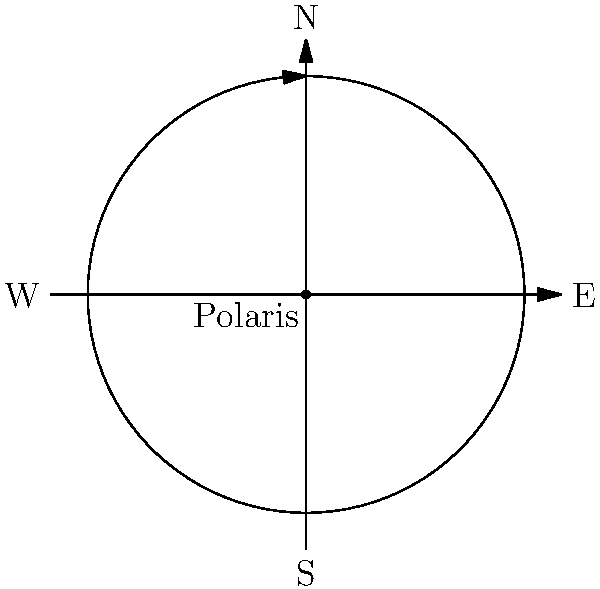Oh, enlightened stargazer, behold this celestial portrait of stellar narcissism! If one were to capture the apparent motion of stars over the course of a night using long-exposure photography, which philosophical conundrum would this circular pattern around Polaris most closely resemble: Nietzsche's eternal recurrence or Plato's allegory of the cave? Let's deconstruct this cosmic spectacle with the irreverence it deserves:

1. The diagram shows a circular pattern around a central point labeled "Polaris," our cosmic narcissist.

2. This pattern represents star trails, the apparent motion of stars in the night sky as observed from Earth.

3. The circular motion occurs because:
   a) Earth rotates on its axis.
   b) Polaris, our celestial anchor, is aligned with Earth's rotational axis.

4. Now, for the philosophical musings:
   a) Nietzsche's eternal recurrence posits that the universe and all existence recur infinitely.
   b) Plato's allegory of the cave suggests that our perceptions may not reflect true reality.

5. The star trail pattern:
   a) Repeats nightly, echoing Nietzsche's concept of cyclical existence.
   b) Is an illusion caused by Earth's rotation, not actual star movement, aligning with Plato's skepticism of appearances.

6. However, the question asks which it more closely resembles. The key is in the word "apparent."

7. The star trails are an optical illusion, a mere shadow of the true cosmic dance, much like the shadows on the wall of Plato's cave.

Therefore, this celestial deception more closely aligns with Plato's allegory of the cave, reminding us that our perceptions of the universe may be but mere projections of a greater reality.
Answer: Plato's allegory of the cave 